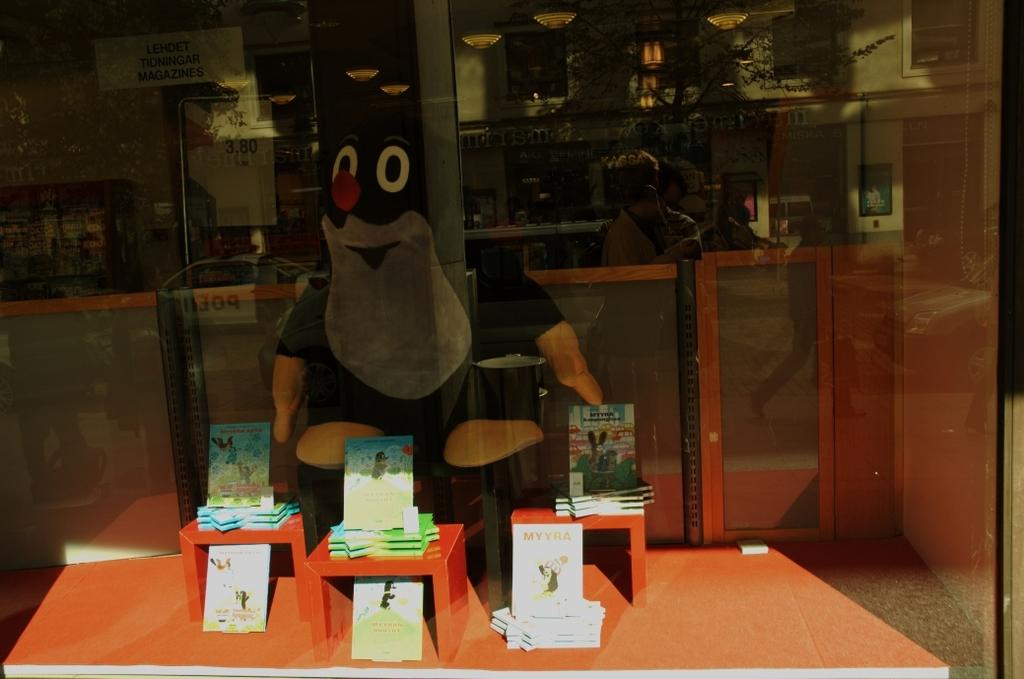What is the main subject in the center of the image? There is a clown in the center of the image. What is located at the bottom of the image? There is a table at the bottom of the image. What is placed on the table? Cards are placed on the table. What can be seen in the image due to the presence of glass? People's reflections are visible on the glass. What is the purpose of the square in the image? There is no square present in the image. How many quarters can be seen in the image? There are no quarters visible in the image. 